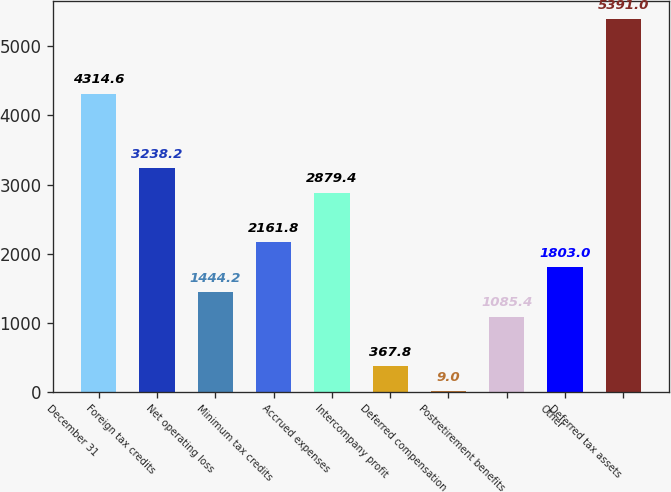<chart> <loc_0><loc_0><loc_500><loc_500><bar_chart><fcel>December 31<fcel>Foreign tax credits<fcel>Net operating loss<fcel>Minimum tax credits<fcel>Accrued expenses<fcel>Intercompany profit<fcel>Deferred compensation<fcel>Postretirement benefits<fcel>Other<fcel>Deferred tax assets<nl><fcel>4314.6<fcel>3238.2<fcel>1444.2<fcel>2161.8<fcel>2879.4<fcel>367.8<fcel>9<fcel>1085.4<fcel>1803<fcel>5391<nl></chart> 